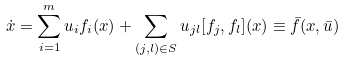Convert formula to latex. <formula><loc_0><loc_0><loc_500><loc_500>\dot { x } = \sum _ { i = 1 } ^ { m } u _ { i } f _ { i } ( x ) + \sum _ { ( j , l ) \in S } u _ { j l } [ f _ { j } , f _ { l } ] ( x ) \equiv \bar { f } ( x , \bar { u } )</formula> 